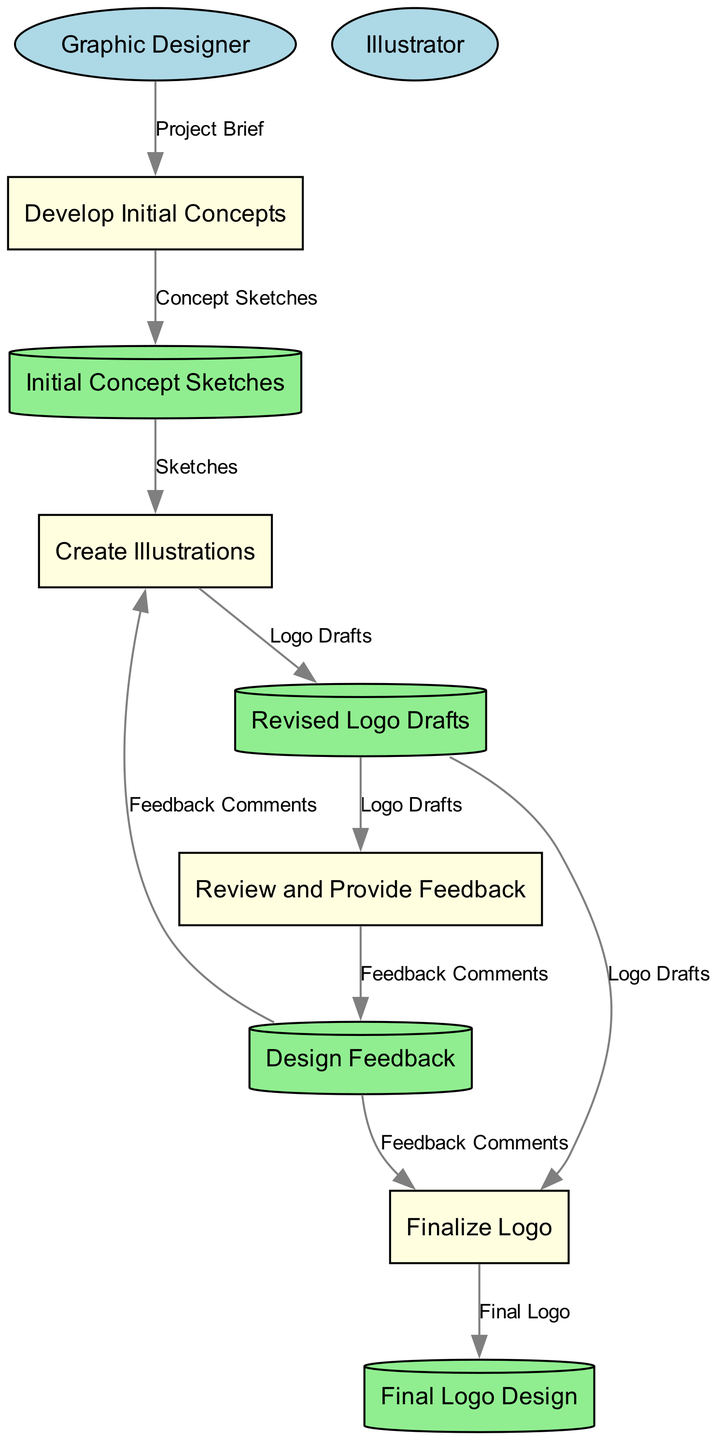What are the two external entities in the diagram? Upon reviewing the diagram, it can be observed that there are two external entities labeled as "Graphic Designer" and "Illustrator." These depict the individuals involved in the workflow process.
Answer: Graphic Designer, Illustrator How many data stores are present in the diagram? The diagram contains four data stores: "Initial Concept Sketches," "Revised Logo Drafts," "Design Feedback," and "Final Logo Design." Each store holds specific data relevant to the graphic design process.
Answer: 4 What is the output of the process "Develop Initial Concepts"? According to the diagram, the output of the process "Develop Initial Concepts" is "Initial Concept Sketches." This indicates that this process generates sketches based on the project brief submitted by the graphic designer.
Answer: Initial Concept Sketches Which process receives input from "Revised Logo Drafts" and "Design Feedback"? The diagram indicates that the process "Finalize Logo" receives inputs from both "Revised Logo Drafts" and "Design Feedback." This suggests that both elements are crucial for finalizing the logo design.
Answer: Finalize Logo How many data flows are there from "Revised Logo Drafts" to other processes? In the diagram, "Revised Logo Drafts" connects to two processes: "Review and Provide Feedback" and "Finalize Logo," resulting in a total of two data flows originating from this node.
Answer: 2 What data element flows from "Review and Provide Feedback" to "Design Feedback"? The data element that flows from "Review and Provide Feedback" to "Design Feedback" is "Feedback Comments." This denotes that feedback on the logo drafts is communicated to be stored for future reference.
Answer: Feedback Comments What information does the "Create Illustrations" process require as input? The "Create Illustrations" process requires two inputs: "Initial Concept Sketches" and "Design Feedback." This indicates that it utilizes both the initial sketches and any feedback given to create the revised drafts.
Answer: Initial Concept Sketches, Design Feedback Which data store holds the final product of the workflow? The final product of the workflow is held in the "Final Logo Design" data store, which represents the completed logo after all processes and feedback have been accounted for.
Answer: Final Logo Design 